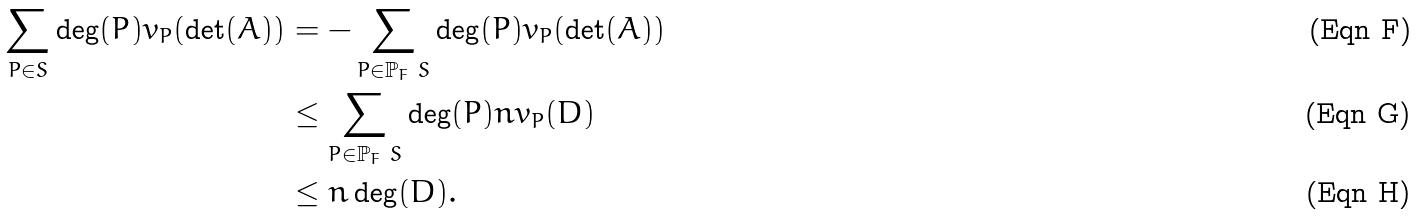Convert formula to latex. <formula><loc_0><loc_0><loc_500><loc_500>\sum _ { P \in S } \deg ( P ) v _ { P } ( \det ( A ) ) & = - \sum _ { P \in \mathbb { P } _ { F } \ S } \deg ( P ) v _ { P } ( \det ( A ) ) \\ & \leq \sum _ { P \in \mathbb { P } _ { F } \ S } \deg ( P ) n v _ { P } ( D ) \\ & \leq n \deg ( D ) .</formula> 